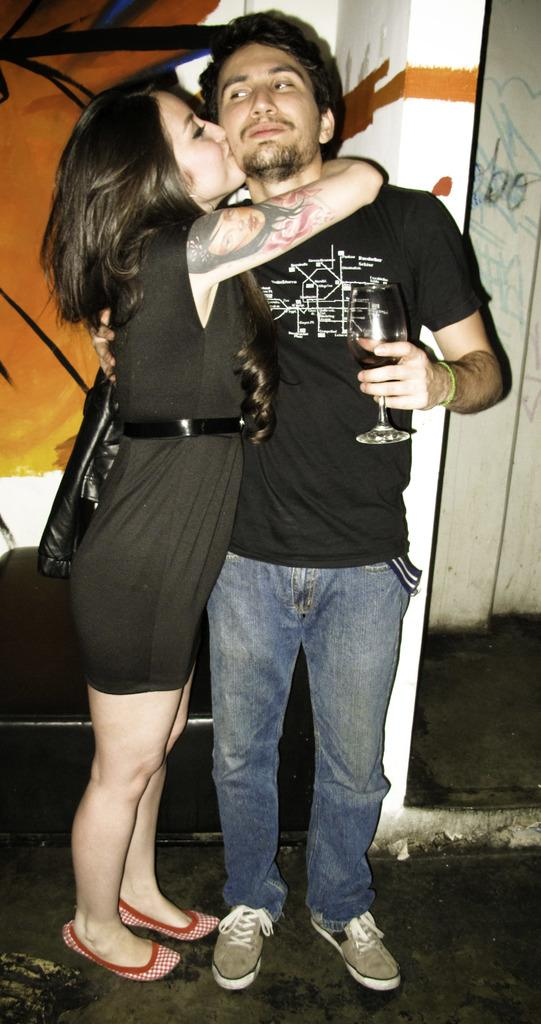How many people are in the image? There are two people in the image, a man and a woman. What is the man holding in the image? The man is holding a glass with a drink. What object can be seen in the image that might be used for carrying items? There is a bag in the image. What can be seen in the background of the image? There is a wall in the background of the image. What type of houses can be seen in the image? There are no houses present in the image. What is the woman using to protect herself from the rain in the image? There is no rain or umbrella present in the image. 